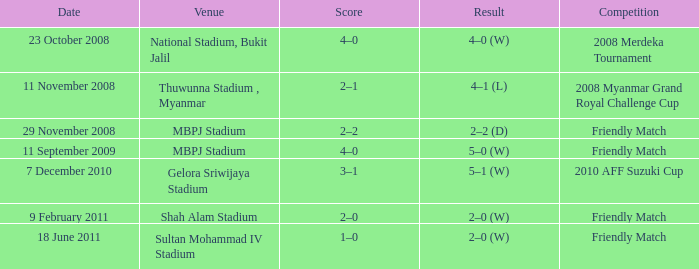What is the aftermath of the championship at mbpj stadium with a score of 4–0? 5–0 (W). 